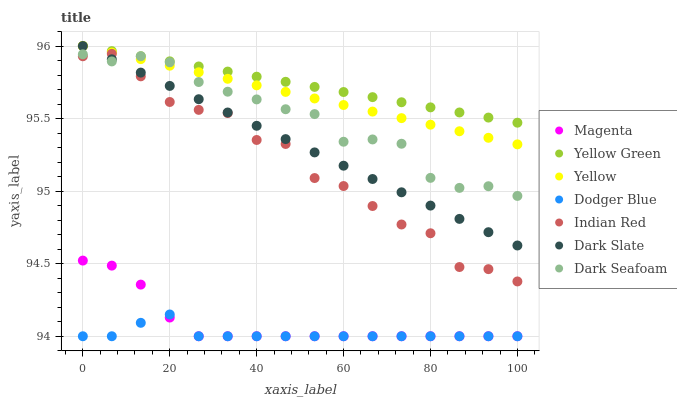Does Dodger Blue have the minimum area under the curve?
Answer yes or no. Yes. Does Yellow Green have the maximum area under the curve?
Answer yes or no. Yes. Does Yellow have the minimum area under the curve?
Answer yes or no. No. Does Yellow have the maximum area under the curve?
Answer yes or no. No. Is Yellow the smoothest?
Answer yes or no. Yes. Is Indian Red the roughest?
Answer yes or no. Yes. Is Dark Slate the smoothest?
Answer yes or no. No. Is Dark Slate the roughest?
Answer yes or no. No. Does Dodger Blue have the lowest value?
Answer yes or no. Yes. Does Yellow have the lowest value?
Answer yes or no. No. Does Dark Slate have the highest value?
Answer yes or no. Yes. Does Dark Seafoam have the highest value?
Answer yes or no. No. Is Indian Red less than Yellow?
Answer yes or no. Yes. Is Dark Seafoam greater than Magenta?
Answer yes or no. Yes. Does Magenta intersect Dodger Blue?
Answer yes or no. Yes. Is Magenta less than Dodger Blue?
Answer yes or no. No. Is Magenta greater than Dodger Blue?
Answer yes or no. No. Does Indian Red intersect Yellow?
Answer yes or no. No. 